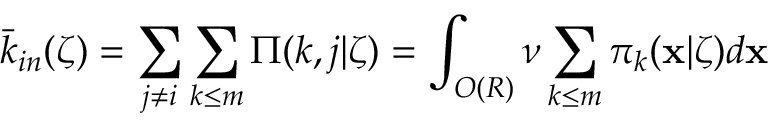Convert formula to latex. <formula><loc_0><loc_0><loc_500><loc_500>\bar { k } _ { i n } ( \zeta ) = \sum _ { j \neq i } \sum _ { k \leq m } \Pi ( k , j | \zeta ) = \int _ { O ( R ) } \nu \sum _ { k \leq m } \pi _ { k } ( \mathbf x | \zeta ) d \mathbf x</formula> 